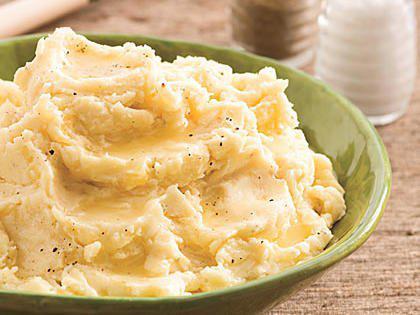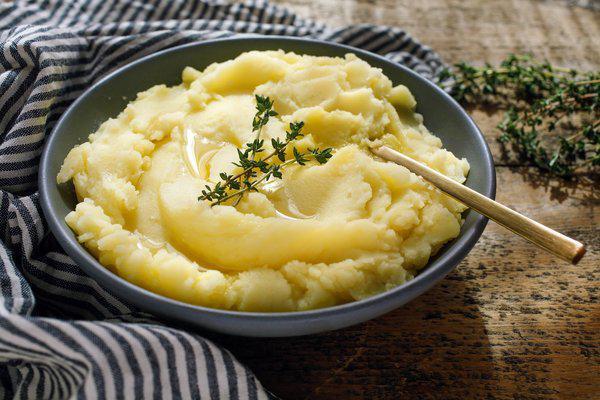The first image is the image on the left, the second image is the image on the right. Analyze the images presented: Is the assertion "There is a green additive to the bowl on the right, such as parsley." valid? Answer yes or no. Yes. The first image is the image on the left, the second image is the image on the right. Considering the images on both sides, is "A utensil with a handle is in one round bowl of mashed potatoes." valid? Answer yes or no. Yes. 